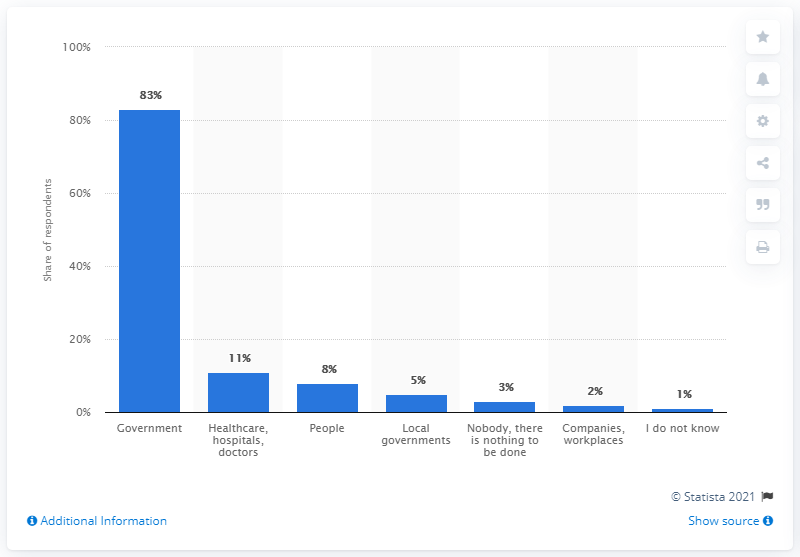Indicate a few pertinent items in this graphic. According to a recent survey conducted in Hungary, 11% of respondents believed that healthcare workers were responsible for providing adequate information on the virus. 